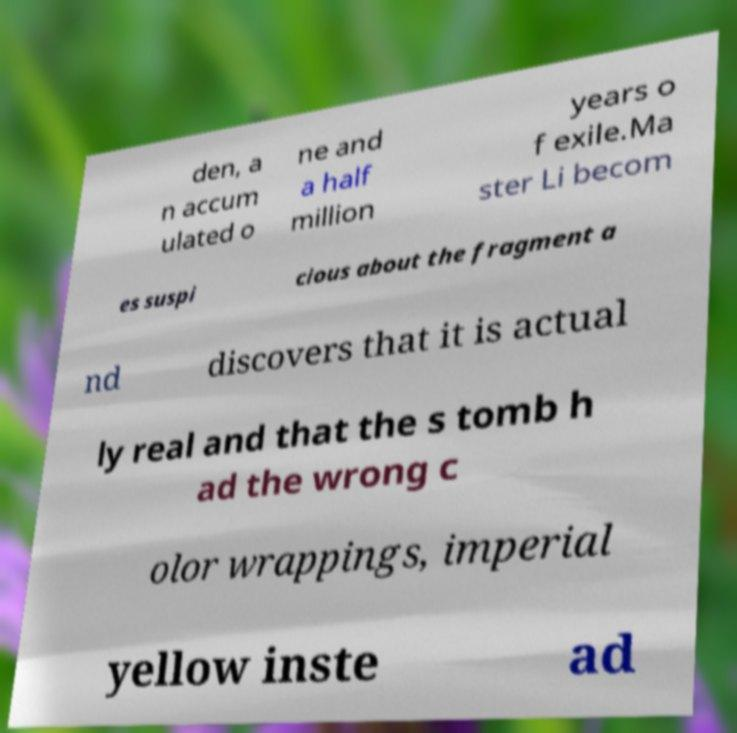Can you accurately transcribe the text from the provided image for me? den, a n accum ulated o ne and a half million years o f exile.Ma ster Li becom es suspi cious about the fragment a nd discovers that it is actual ly real and that the s tomb h ad the wrong c olor wrappings, imperial yellow inste ad 